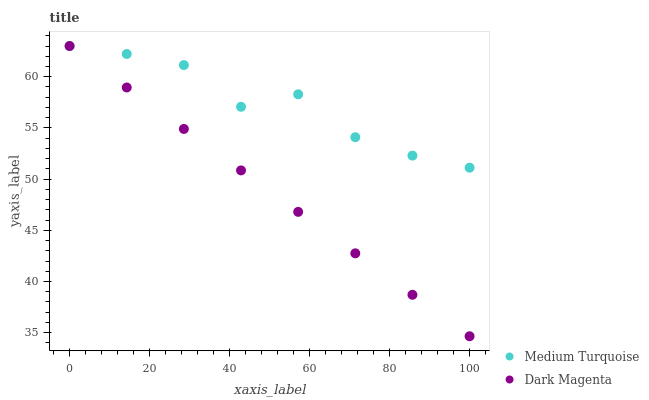Does Dark Magenta have the minimum area under the curve?
Answer yes or no. Yes. Does Medium Turquoise have the maximum area under the curve?
Answer yes or no. Yes. Does Medium Turquoise have the minimum area under the curve?
Answer yes or no. No. Is Dark Magenta the smoothest?
Answer yes or no. Yes. Is Medium Turquoise the roughest?
Answer yes or no. Yes. Is Medium Turquoise the smoothest?
Answer yes or no. No. Does Dark Magenta have the lowest value?
Answer yes or no. Yes. Does Medium Turquoise have the lowest value?
Answer yes or no. No. Does Medium Turquoise have the highest value?
Answer yes or no. Yes. Does Medium Turquoise intersect Dark Magenta?
Answer yes or no. Yes. Is Medium Turquoise less than Dark Magenta?
Answer yes or no. No. Is Medium Turquoise greater than Dark Magenta?
Answer yes or no. No. 